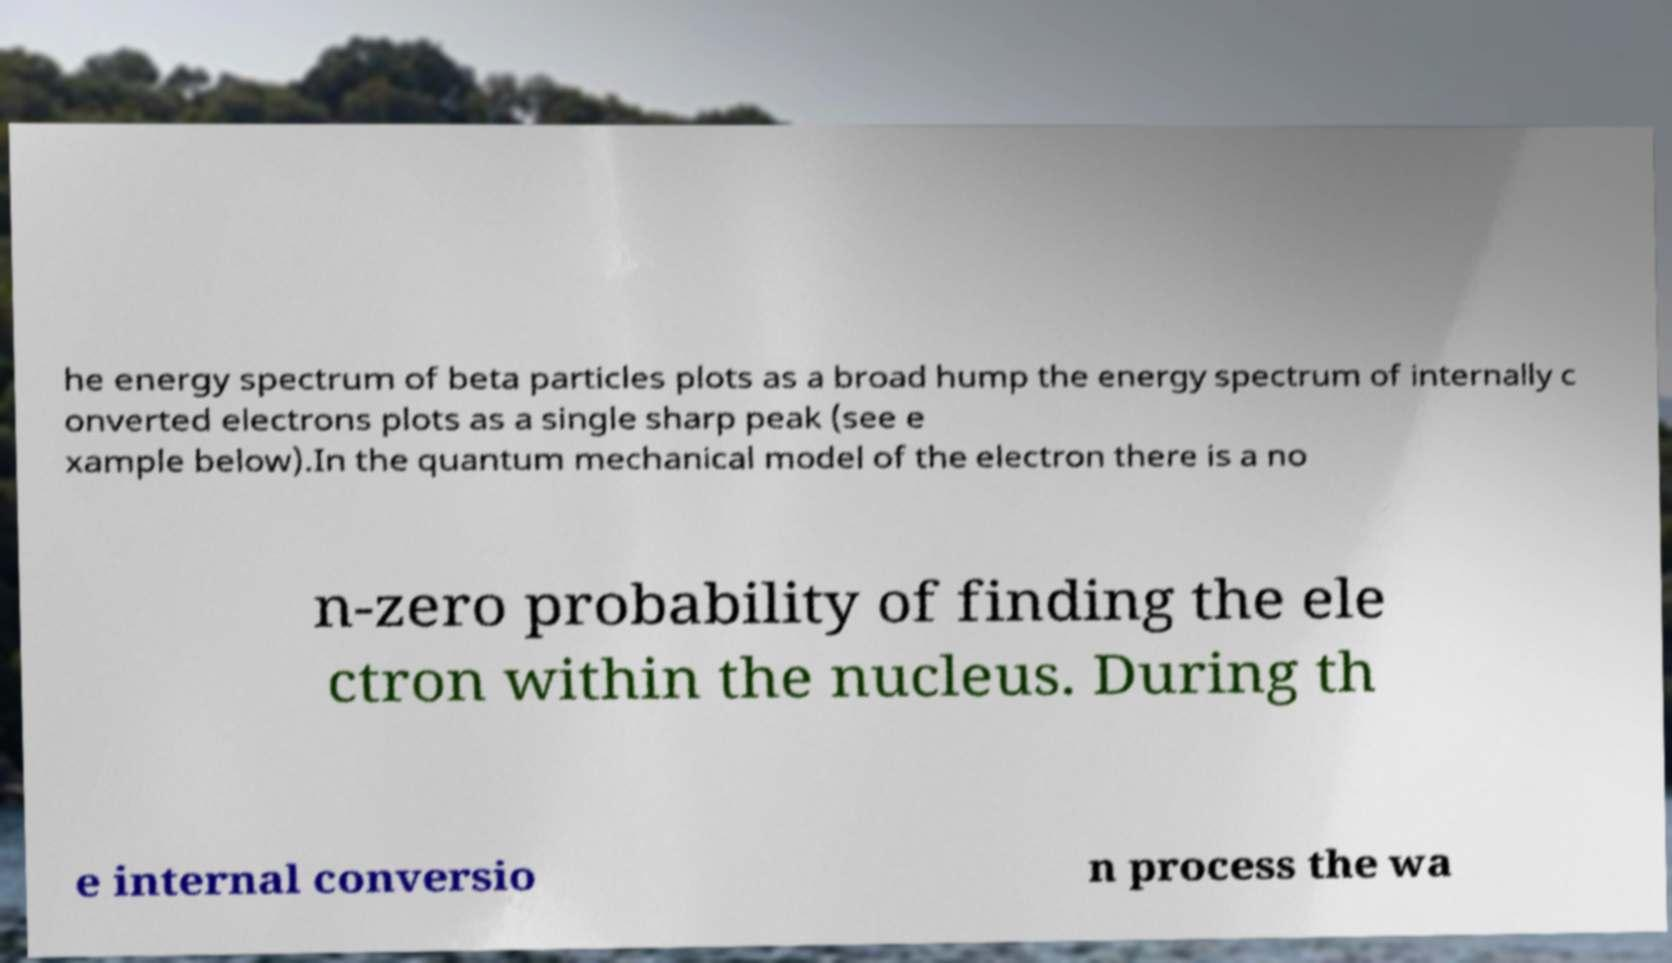Please read and relay the text visible in this image. What does it say? he energy spectrum of beta particles plots as a broad hump the energy spectrum of internally c onverted electrons plots as a single sharp peak (see e xample below).In the quantum mechanical model of the electron there is a no n-zero probability of finding the ele ctron within the nucleus. During th e internal conversio n process the wa 